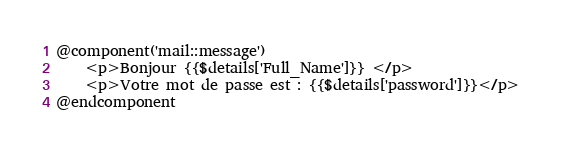Convert code to text. <code><loc_0><loc_0><loc_500><loc_500><_PHP_>@component('mail::message')
    <p>Bonjour {{$details['Full_Name']}} </p>
    <p>Votre mot de passe est : {{$details['password']}}</p>
@endcomponent
</code> 